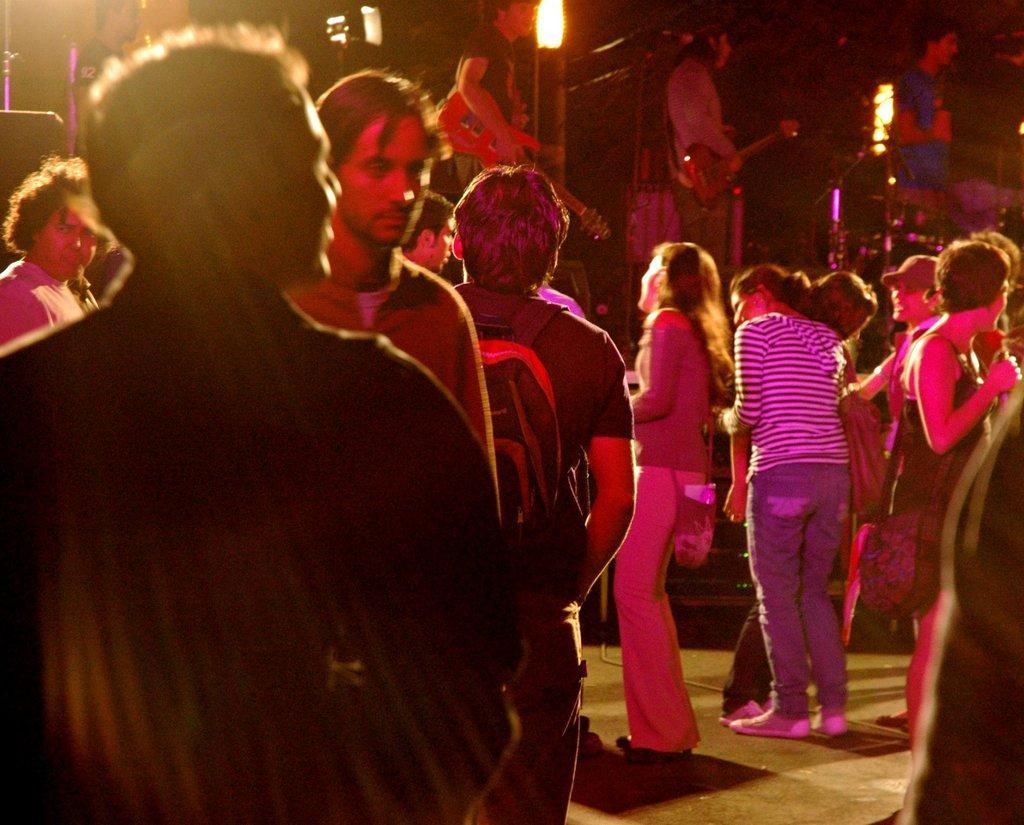Please provide a concise description of this image. We can see group of people. In the background there are two people standing and holding guitars and we can see lights. 